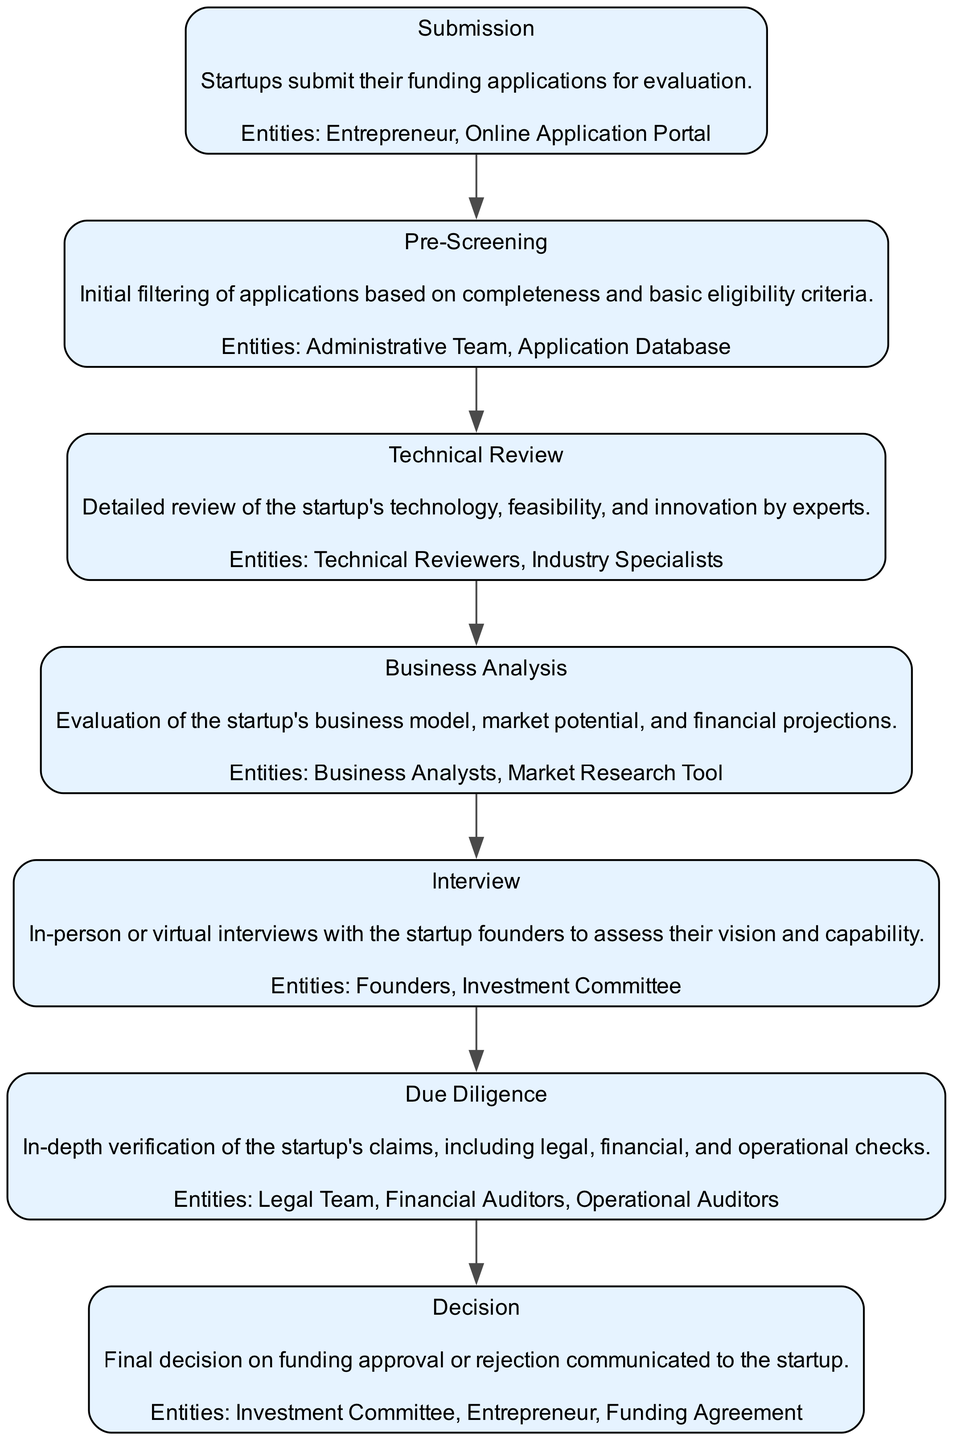What is the first stage in the funding application evaluation process? The first stage, as defined in the diagram, is labeled "Submission". It is the stage where startups submit their funding applications.
Answer: Submission How many entities are involved in the "Technical Review" stage? The "Technical Review" stage involves two entities: "Technical Reviewers" and "Industry Specialists". Thus, the total count of entities is two.
Answer: 2 What is the last stage before the "Decision"? The last stage before the "Decision" is "Due Diligence". It is the stage that involves in-depth verification of the startup's claims prior to making a decision.
Answer: Due Diligence Which entities are involved in the "Business Analysis" stage? The "Business Analysis" stage is carried out by "Business Analysts" using a "Market Research Tool". This indicates that these two entities are responsible for this stage's evaluation process.
Answer: Business Analysts, Market Research Tool What is the primary focus of the "Pre-Screening" stage? The "Pre-Screening" stage focuses on the initial filtering of applications based on their completeness and basic eligibility criteria. It serves as the first layer of evaluation.
Answer: Initial filtering of applications How does the "Interview" stage relate to the "Submission"? The "Interview" stage occurs after the "Submission" stage, as derived from the flow of the diagram which shows a directional edge from "Submission" to "Interview". This indicates that once applications are submitted, interviews are conducted next.
Answer: Occurs after What is evaluated during the "Due Diligence" stage? The "Due Diligence" stage evaluates the startup's claims, including legal, financial, and operational aspects. This stage's purpose is to verify the accuracy of claims made by the startup.
Answer: Legal, financial, and operational checks Which team conducts the "Technical Review"? The "Technical Review" is conducted by "Technical Reviewers" and "Industry Specialists". These entities are tasked with providing detailed evaluations of the startup's technology.
Answer: Technical Reviewers, Industry Specialists 